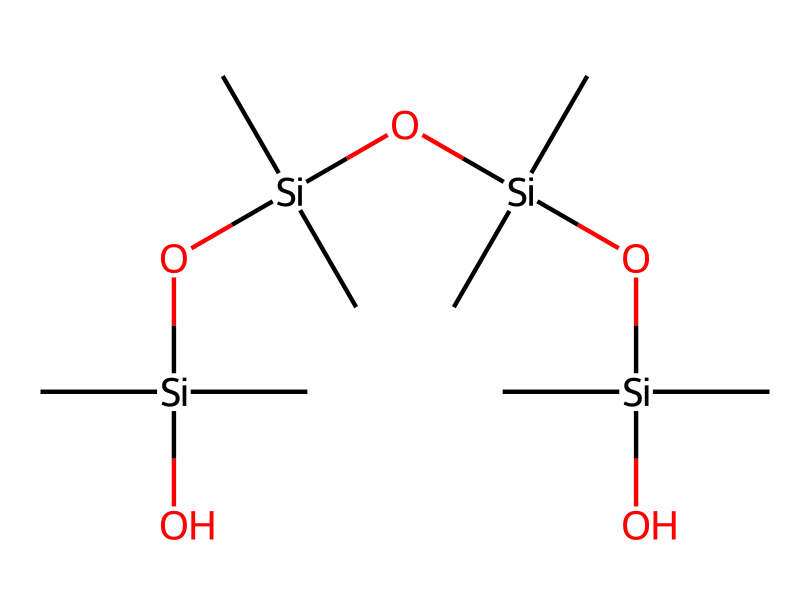How many silicon atoms are present in the chemical structure? By examining the SMILES representation, we count the number of 'Si' that appears. There are four silicon atoms in the structure.
Answer: four What is the overall structure type of this compound? The presence of silicon (Si) and oxygen (O) atoms in the structure indicates that this compound is an organosilicon compound, specifically a type of silicone.
Answer: silicone How many hydroxyl groups are in the compound? Each 'O' in the SMILES that has a single bond to a silicon atom indicates a hydroxyl group. In this structure, there are four hydroxyl groups connected to the silicon atoms.
Answer: four What functional group is present in this structure? The presence of the -Si-O- and -OH combinations indicates that the primary functional group is silanol, which is characteristic of organosilicon compounds.
Answer: silanol What is the significance of the repeating units in the structure? The repeating -Si(O)- groups indicate polymeric characteristics, meaning this compound can form long chains or networks, which is essential for flexible silicone baking molds.
Answer: polymeric characteristics 